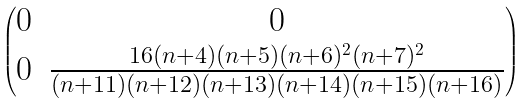<formula> <loc_0><loc_0><loc_500><loc_500>\begin{pmatrix} 0 & 0 \\ 0 & \frac { 1 6 ( n + 4 ) ( n + 5 ) ( n + 6 ) ^ { 2 } ( n + 7 ) ^ { 2 } } { ( n + 1 1 ) ( n + 1 2 ) ( n + 1 3 ) ( n + 1 4 ) ( n + 1 5 ) ( n + 1 6 ) } \end{pmatrix}</formula> 